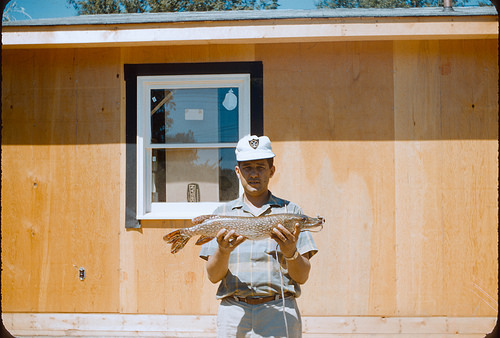<image>
Is the fish on the man? Yes. Looking at the image, I can see the fish is positioned on top of the man, with the man providing support. 